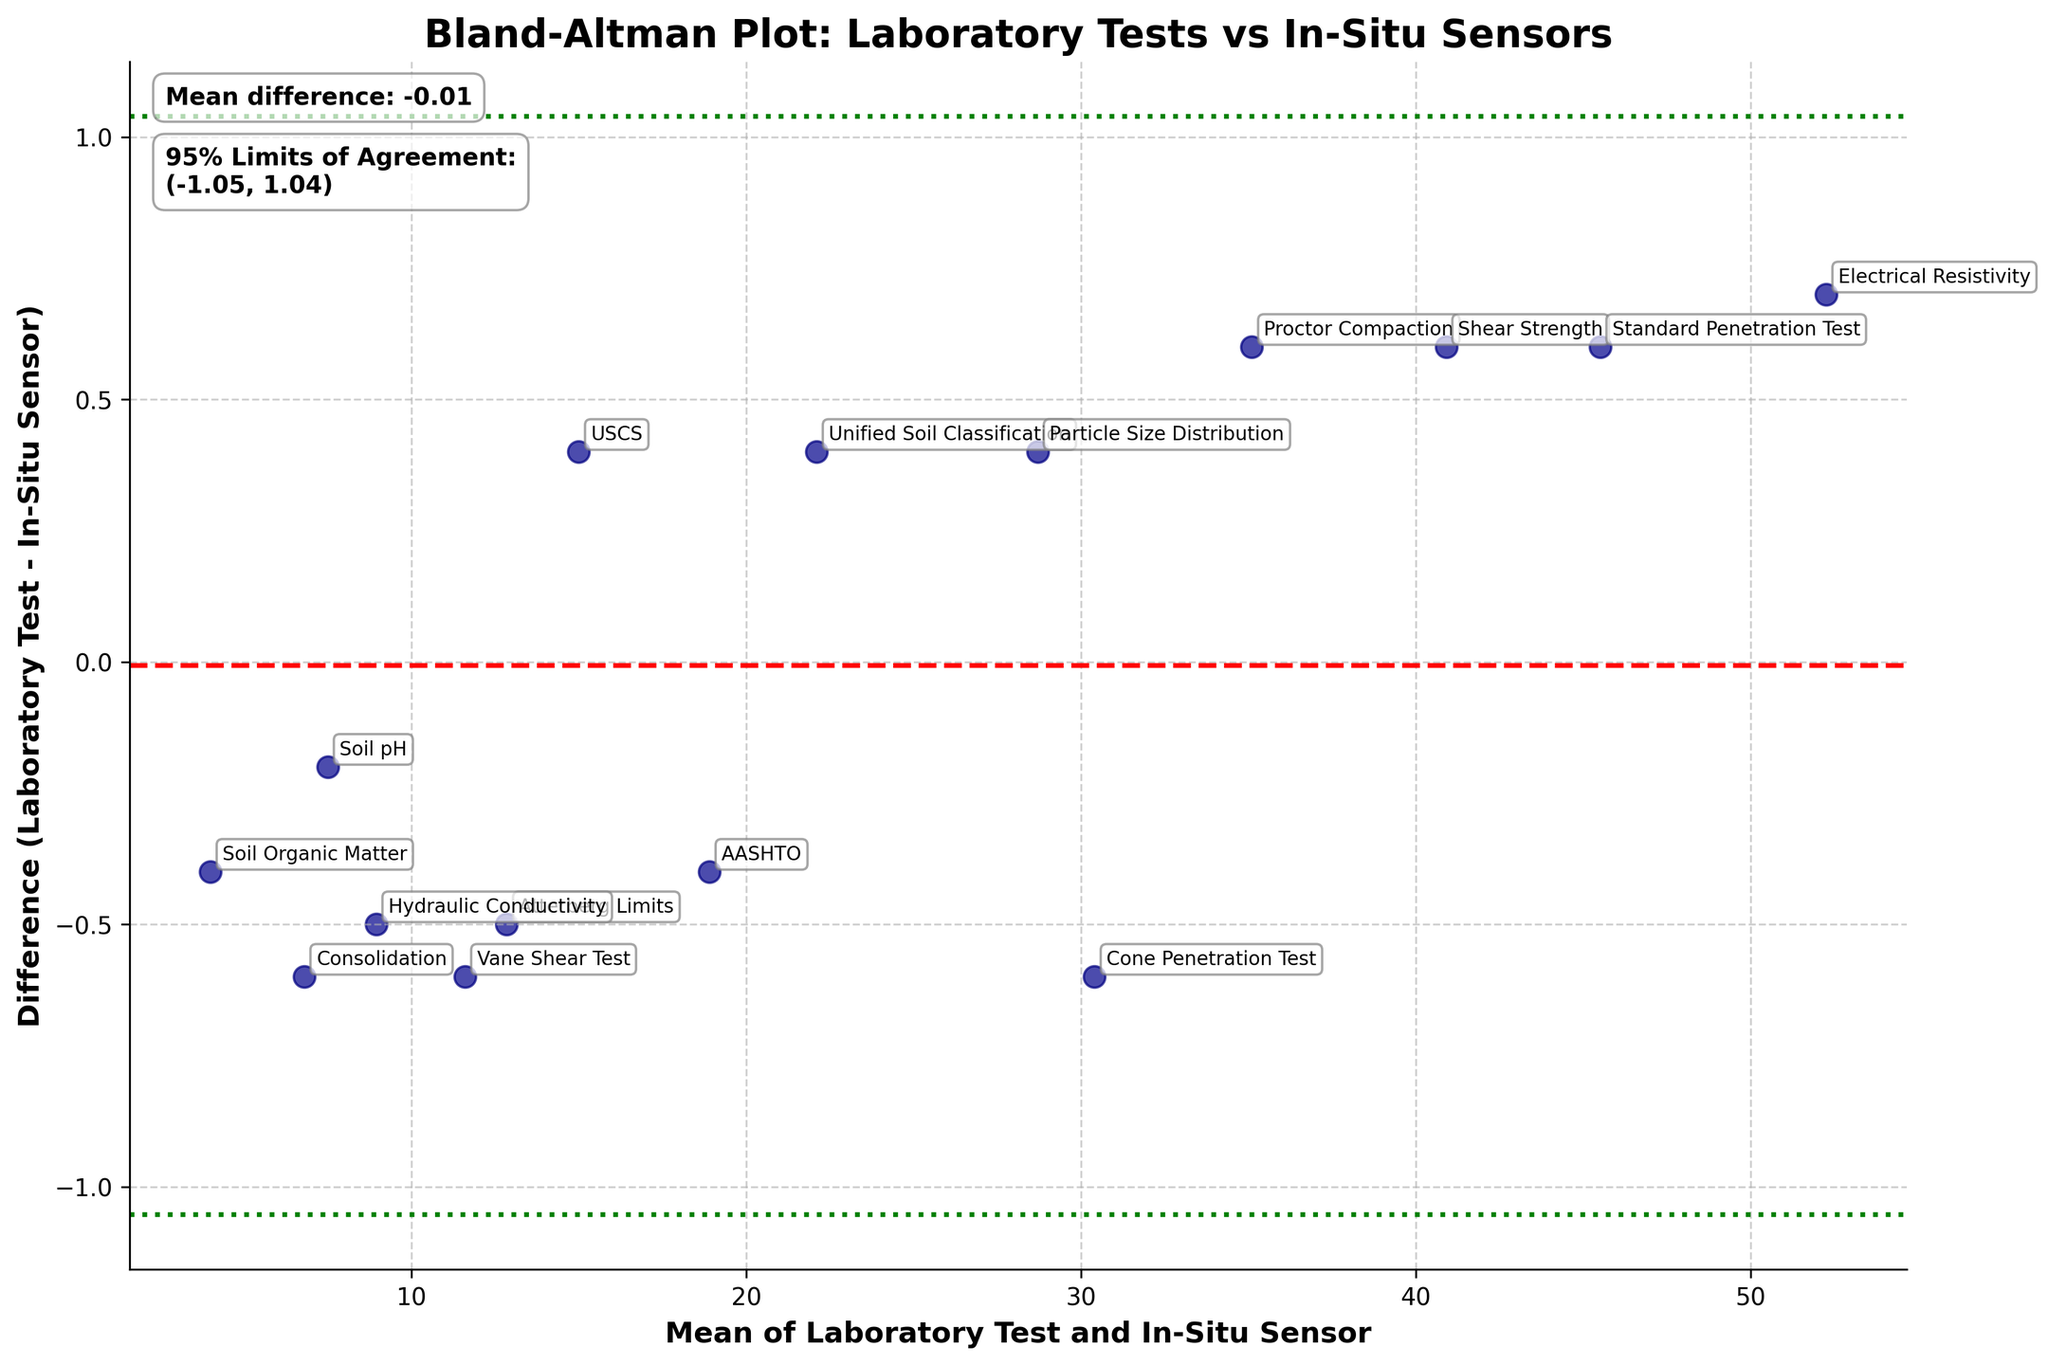What's the title of this figure? The title is written at the top of the figure in bold and regular font.
Answer: Bland-Altman Plot: Laboratory Tests vs In-Situ Sensors How many methods are compared in this plot? Each point in the plot represents a method, which can be counted by looking at the unique annotations next to each point.
Answer: 15 What's the mean difference between the Laboratory Test and In-Situ Sensor measurements? The mean difference is indicated by the red dashed line and is also explicitly mentioned on the left side of the plot.
Answer: 0.07 Which method has the largest difference between Laboratory Test and In-Situ Sensor? By observing the vertical distances from the horizontal axis (mean difference line) to the points, the point corresponding to the largest positive or negative value indicates the largest difference.
Answer: Shear Strength What's the average of the Laboratory Test and In-Situ Sensor for the method 'Soil pH'? The average is identified by the x-coordinate of the annotated data point for 'Soil pH', i.e., the middle value between Laboratory Test and In-Situ Sensor for this method.
Answer: 7.5 How do the 95% Limits of Agreement help in interpreting this plot? These limits (green dotted lines) provide a range around the mean difference where most differences between Laboratory Test and In-Situ Sensor measurements are expected to lie, indicating the agreement extent.
Answer: Provide agreement range Which method shows the smallest mean among the rest? By examining the x-coordinates of all data points, the one closest to the lower end of the x-axis represents the smallest mean.
Answer: Soil Organic Matter Is the difference for 'Particle Size Distribution' within the 95% Limits of Agreement? Check if the vertical position (difference) of the 'Particle Size Distribution' point lies between the two green dotted lines.
Answer: Yes What does a data point above the mean difference indicate in this plot? Data points above the mean difference (red dashed line) imply that the Laboratory Test result is higher than the In-Situ Sensor result for that method.
Answer: Laboratory Test > In-Situ Sensor For which method is the mean value almost 35? Identify the method based on its x-coordinate being closest to 35, while referring to the annotations.
Answer: Proctor Compaction 